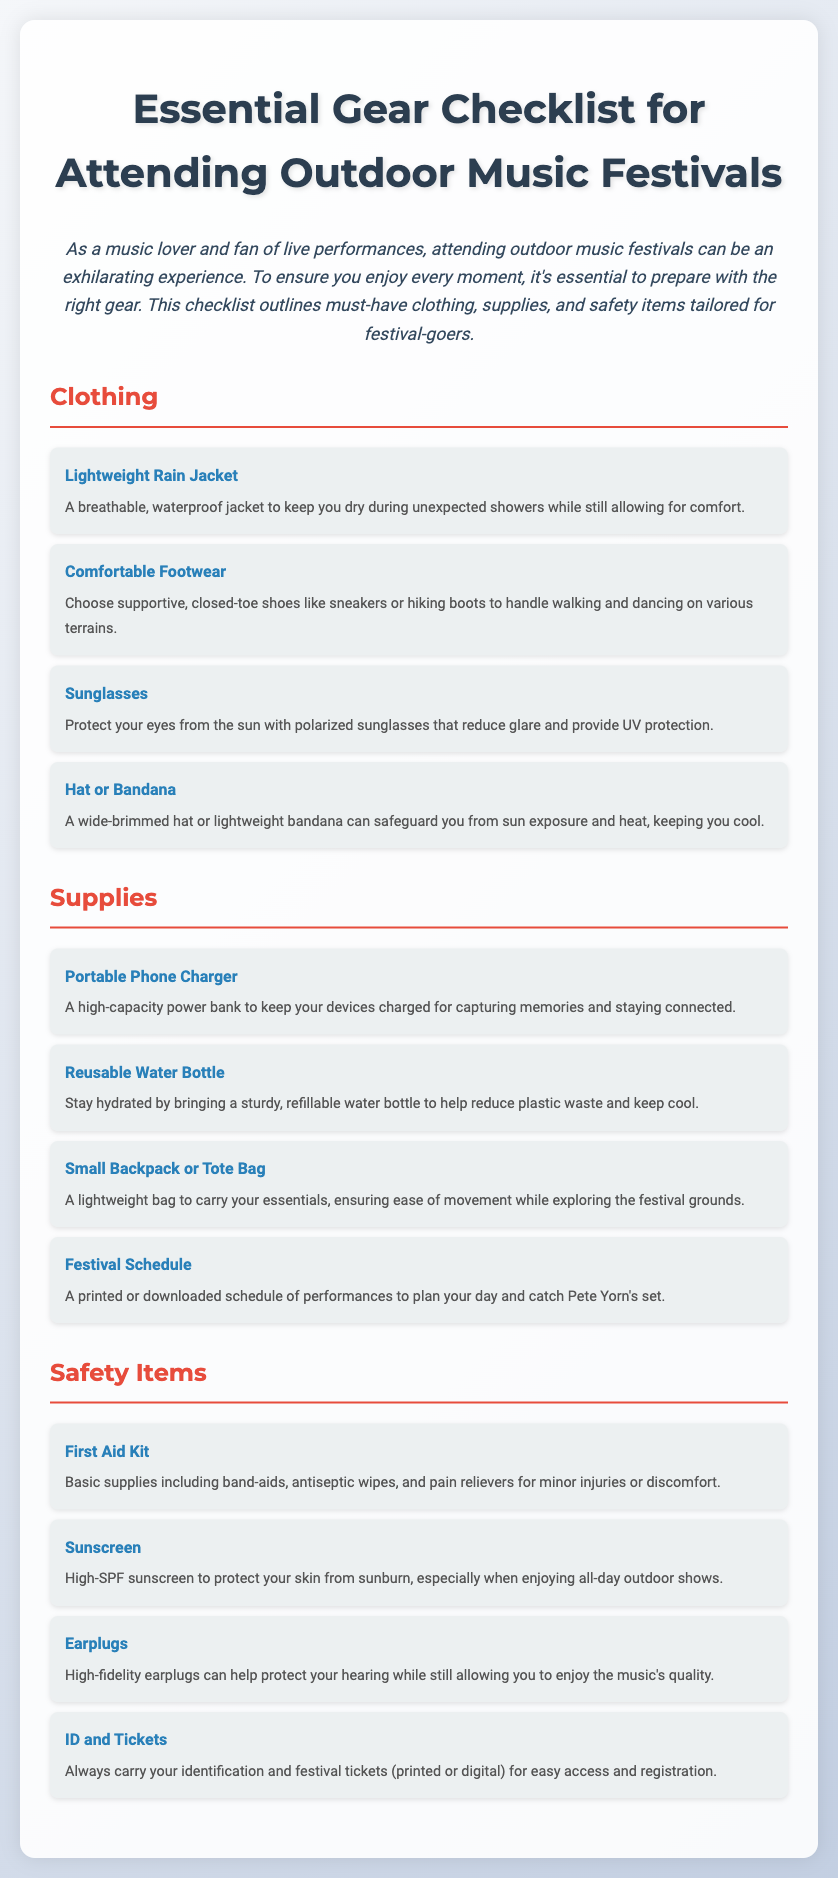what is the title of the document? The title is clearly stated at the top of the document as "Essential Gear Checklist for Attending Outdoor Music Festivals."
Answer: Essential Gear Checklist for Attending Outdoor Music Festivals how many sections are in the document? There are three main sections in the document: Clothing, Supplies, and Safety Items.
Answer: 3 what type of footwear is recommended? The document specifies that supportive, closed-toe shoes like sneakers or hiking boots are recommended.
Answer: Comfortable Footwear what is a suggested item to protect your skin? The document mentions high-SPF sunscreen as a necessary item for skin protection from sunburn.
Answer: Sunscreen why is a portable phone charger important? It is important to keep your devices charged for capturing memories and staying connected during the festival.
Answer: To keep devices charged name one item to help you stay hydrated. The checklist suggests bringing a reusable water bottle to help stay hydrated.
Answer: Reusable Water Bottle what should you carry for easy access and registration? The document emphasizes carrying your identification and festival tickets for easy access and registration.
Answer: ID and Tickets which item is specifically mentioned for Pete Yorn’s performance? A festival schedule is mentioned as necessary to plan your day and catch Pete Yorn's set.
Answer: Festival Schedule 